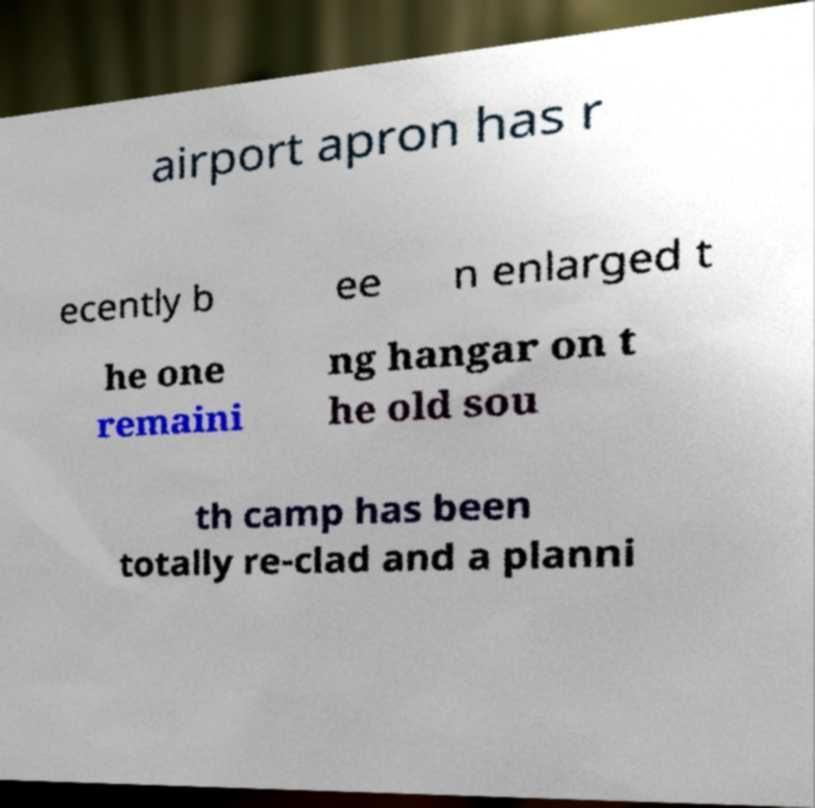Could you extract and type out the text from this image? airport apron has r ecently b ee n enlarged t he one remaini ng hangar on t he old sou th camp has been totally re-clad and a planni 